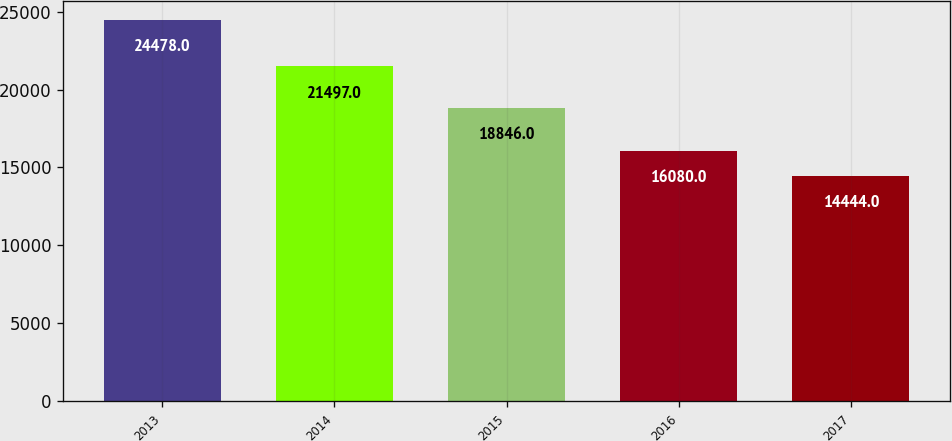Convert chart. <chart><loc_0><loc_0><loc_500><loc_500><bar_chart><fcel>2013<fcel>2014<fcel>2015<fcel>2016<fcel>2017<nl><fcel>24478<fcel>21497<fcel>18846<fcel>16080<fcel>14444<nl></chart> 